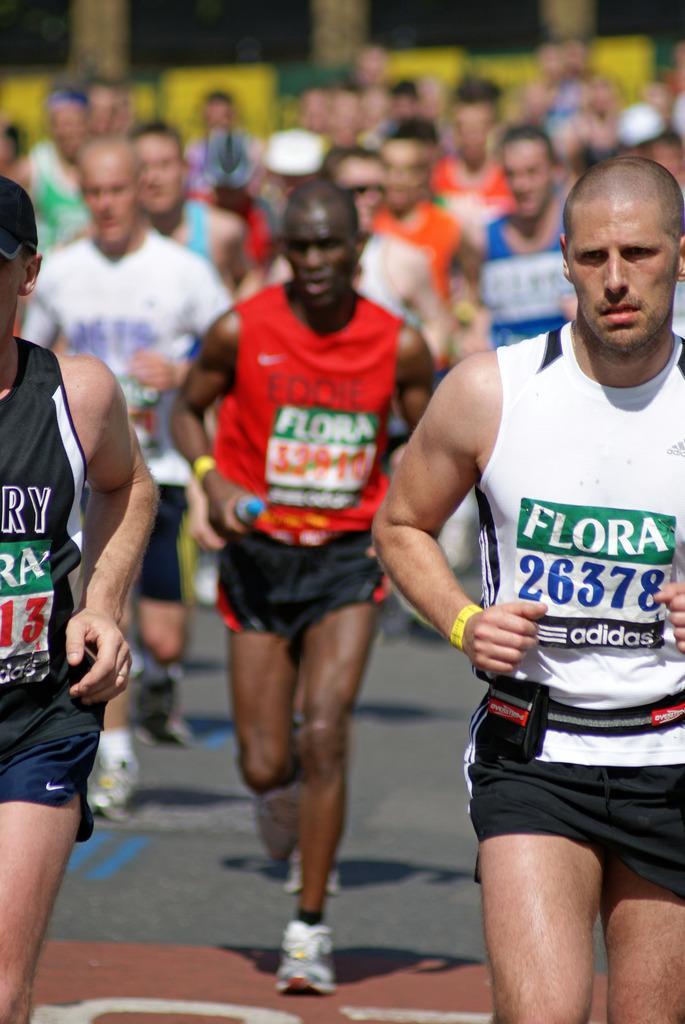<image>
Present a compact description of the photo's key features. The man wearing the white shirt has a bib number that says "26378." 